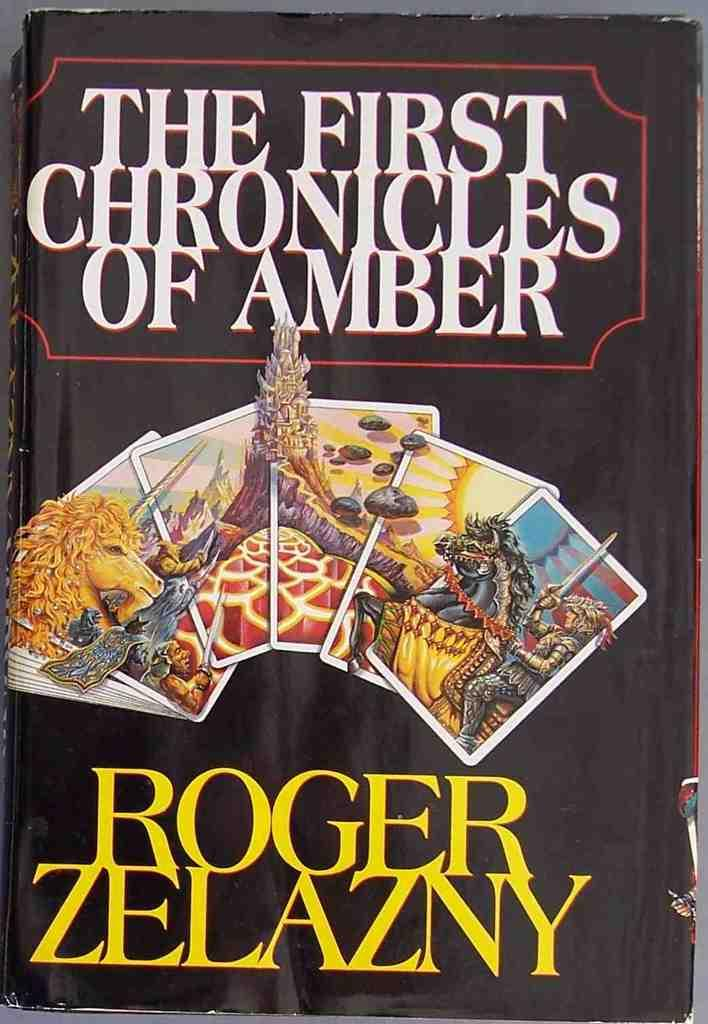What object is present on the table in the image? There is a book on the table in the image. What is the primary purpose of the book? The book has text and images on it, suggesting it is meant for reading or viewing. Can you describe the book's appearance? The book has text and images on it. What type of zipper is used to hold the book together? There is no mention of a zipper in the image or the provided facts, as the book appears to be a traditional bound book. 